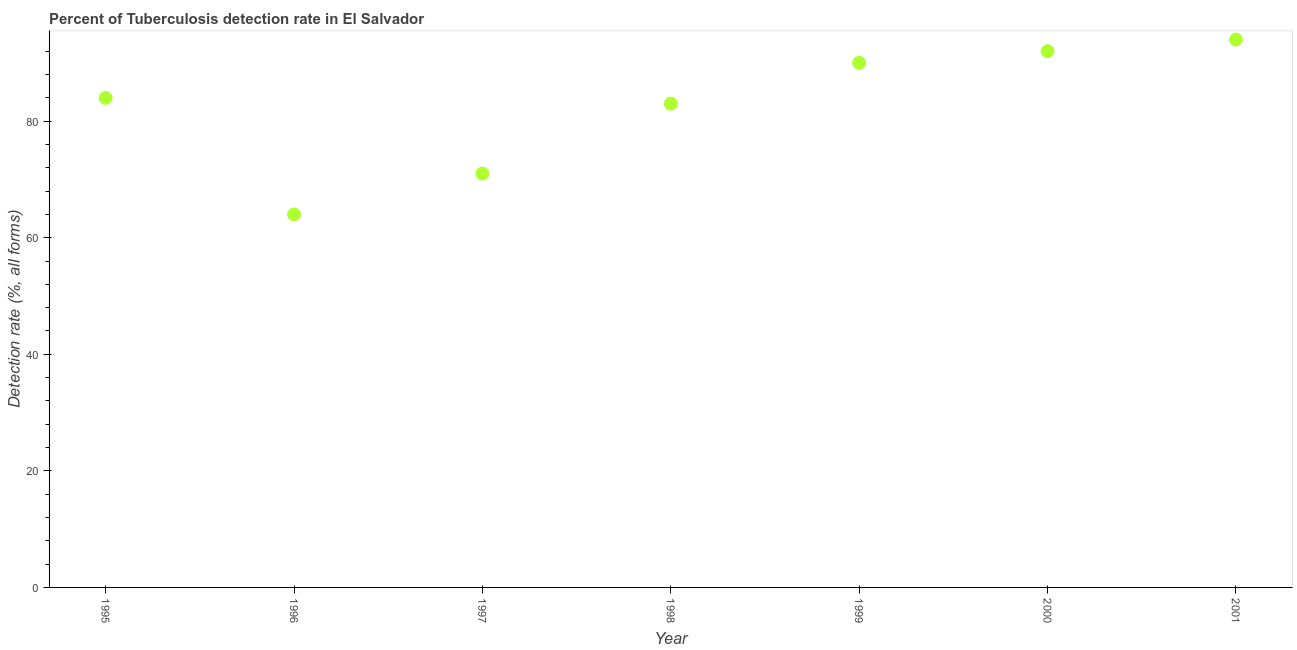What is the detection rate of tuberculosis in 1995?
Provide a short and direct response. 84. Across all years, what is the maximum detection rate of tuberculosis?
Keep it short and to the point. 94. Across all years, what is the minimum detection rate of tuberculosis?
Provide a short and direct response. 64. In which year was the detection rate of tuberculosis maximum?
Provide a succinct answer. 2001. In which year was the detection rate of tuberculosis minimum?
Ensure brevity in your answer.  1996. What is the sum of the detection rate of tuberculosis?
Keep it short and to the point. 578. What is the difference between the detection rate of tuberculosis in 1997 and 2001?
Provide a succinct answer. -23. What is the average detection rate of tuberculosis per year?
Your answer should be very brief. 82.57. What is the median detection rate of tuberculosis?
Offer a very short reply. 84. In how many years, is the detection rate of tuberculosis greater than 36 %?
Offer a very short reply. 7. What is the ratio of the detection rate of tuberculosis in 1999 to that in 2000?
Offer a very short reply. 0.98. Is the detection rate of tuberculosis in 1995 less than that in 1996?
Give a very brief answer. No. Is the difference between the detection rate of tuberculosis in 1996 and 1998 greater than the difference between any two years?
Ensure brevity in your answer.  No. What is the difference between the highest and the lowest detection rate of tuberculosis?
Ensure brevity in your answer.  30. How many dotlines are there?
Make the answer very short. 1. How many years are there in the graph?
Provide a short and direct response. 7. What is the difference between two consecutive major ticks on the Y-axis?
Ensure brevity in your answer.  20. Are the values on the major ticks of Y-axis written in scientific E-notation?
Provide a succinct answer. No. What is the title of the graph?
Your response must be concise. Percent of Tuberculosis detection rate in El Salvador. What is the label or title of the X-axis?
Keep it short and to the point. Year. What is the label or title of the Y-axis?
Offer a terse response. Detection rate (%, all forms). What is the Detection rate (%, all forms) in 1996?
Ensure brevity in your answer.  64. What is the Detection rate (%, all forms) in 1998?
Your response must be concise. 83. What is the Detection rate (%, all forms) in 2000?
Offer a very short reply. 92. What is the Detection rate (%, all forms) in 2001?
Keep it short and to the point. 94. What is the difference between the Detection rate (%, all forms) in 1995 and 1996?
Offer a terse response. 20. What is the difference between the Detection rate (%, all forms) in 1995 and 1997?
Your response must be concise. 13. What is the difference between the Detection rate (%, all forms) in 1995 and 1999?
Make the answer very short. -6. What is the difference between the Detection rate (%, all forms) in 1995 and 2001?
Offer a terse response. -10. What is the difference between the Detection rate (%, all forms) in 1996 and 1997?
Provide a short and direct response. -7. What is the difference between the Detection rate (%, all forms) in 1996 and 2000?
Make the answer very short. -28. What is the difference between the Detection rate (%, all forms) in 1996 and 2001?
Ensure brevity in your answer.  -30. What is the difference between the Detection rate (%, all forms) in 1997 and 2000?
Give a very brief answer. -21. What is the difference between the Detection rate (%, all forms) in 1997 and 2001?
Offer a very short reply. -23. What is the difference between the Detection rate (%, all forms) in 1998 and 1999?
Ensure brevity in your answer.  -7. What is the difference between the Detection rate (%, all forms) in 1998 and 2000?
Your answer should be very brief. -9. What is the difference between the Detection rate (%, all forms) in 1999 and 2001?
Your response must be concise. -4. What is the ratio of the Detection rate (%, all forms) in 1995 to that in 1996?
Provide a short and direct response. 1.31. What is the ratio of the Detection rate (%, all forms) in 1995 to that in 1997?
Offer a very short reply. 1.18. What is the ratio of the Detection rate (%, all forms) in 1995 to that in 1999?
Your answer should be very brief. 0.93. What is the ratio of the Detection rate (%, all forms) in 1995 to that in 2001?
Offer a terse response. 0.89. What is the ratio of the Detection rate (%, all forms) in 1996 to that in 1997?
Provide a succinct answer. 0.9. What is the ratio of the Detection rate (%, all forms) in 1996 to that in 1998?
Your answer should be compact. 0.77. What is the ratio of the Detection rate (%, all forms) in 1996 to that in 1999?
Your answer should be compact. 0.71. What is the ratio of the Detection rate (%, all forms) in 1996 to that in 2000?
Keep it short and to the point. 0.7. What is the ratio of the Detection rate (%, all forms) in 1996 to that in 2001?
Provide a succinct answer. 0.68. What is the ratio of the Detection rate (%, all forms) in 1997 to that in 1998?
Provide a succinct answer. 0.85. What is the ratio of the Detection rate (%, all forms) in 1997 to that in 1999?
Ensure brevity in your answer.  0.79. What is the ratio of the Detection rate (%, all forms) in 1997 to that in 2000?
Your response must be concise. 0.77. What is the ratio of the Detection rate (%, all forms) in 1997 to that in 2001?
Keep it short and to the point. 0.76. What is the ratio of the Detection rate (%, all forms) in 1998 to that in 1999?
Offer a very short reply. 0.92. What is the ratio of the Detection rate (%, all forms) in 1998 to that in 2000?
Provide a succinct answer. 0.9. What is the ratio of the Detection rate (%, all forms) in 1998 to that in 2001?
Your answer should be very brief. 0.88. What is the ratio of the Detection rate (%, all forms) in 2000 to that in 2001?
Ensure brevity in your answer.  0.98. 